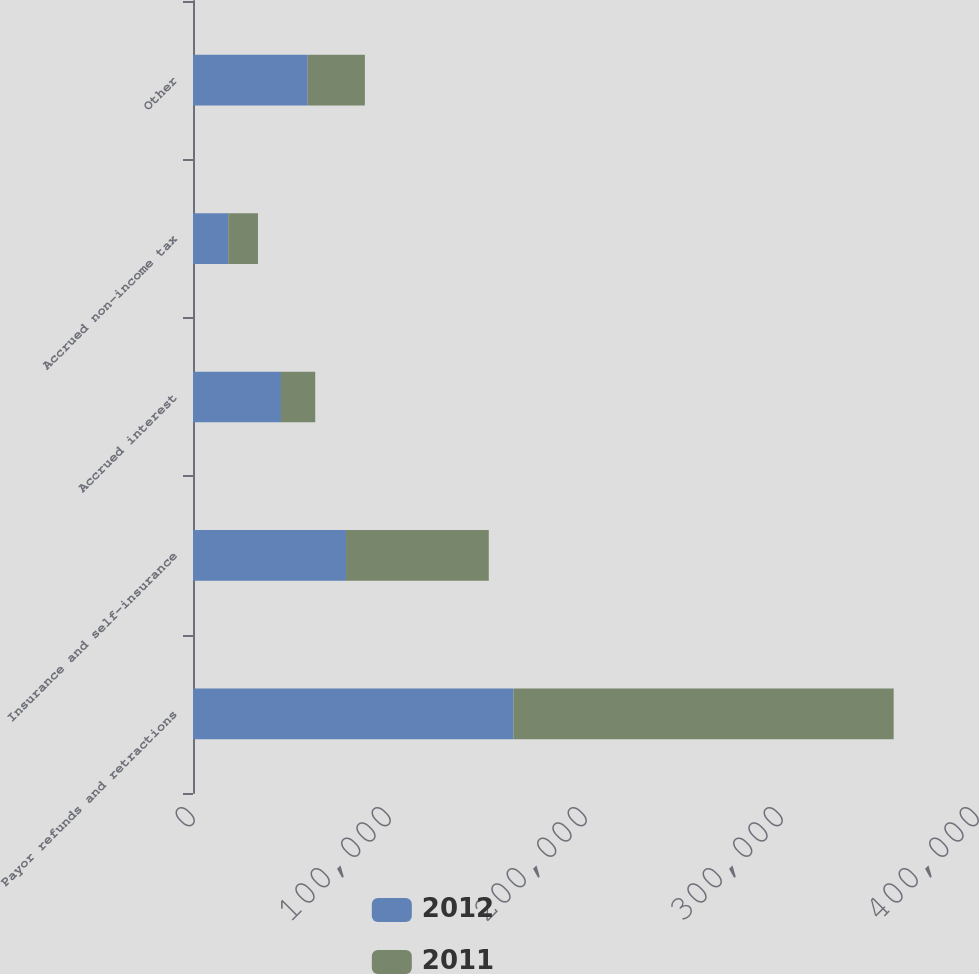Convert chart to OTSL. <chart><loc_0><loc_0><loc_500><loc_500><stacked_bar_chart><ecel><fcel>Payor refunds and retractions<fcel>Insurance and self-insurance<fcel>Accrued interest<fcel>Accrued non-income tax<fcel>Other<nl><fcel>2012<fcel>163520<fcel>78073<fcel>44884<fcel>17976<fcel>58530<nl><fcel>2011<fcel>193966<fcel>72835<fcel>17469<fcel>15174<fcel>29163<nl></chart> 